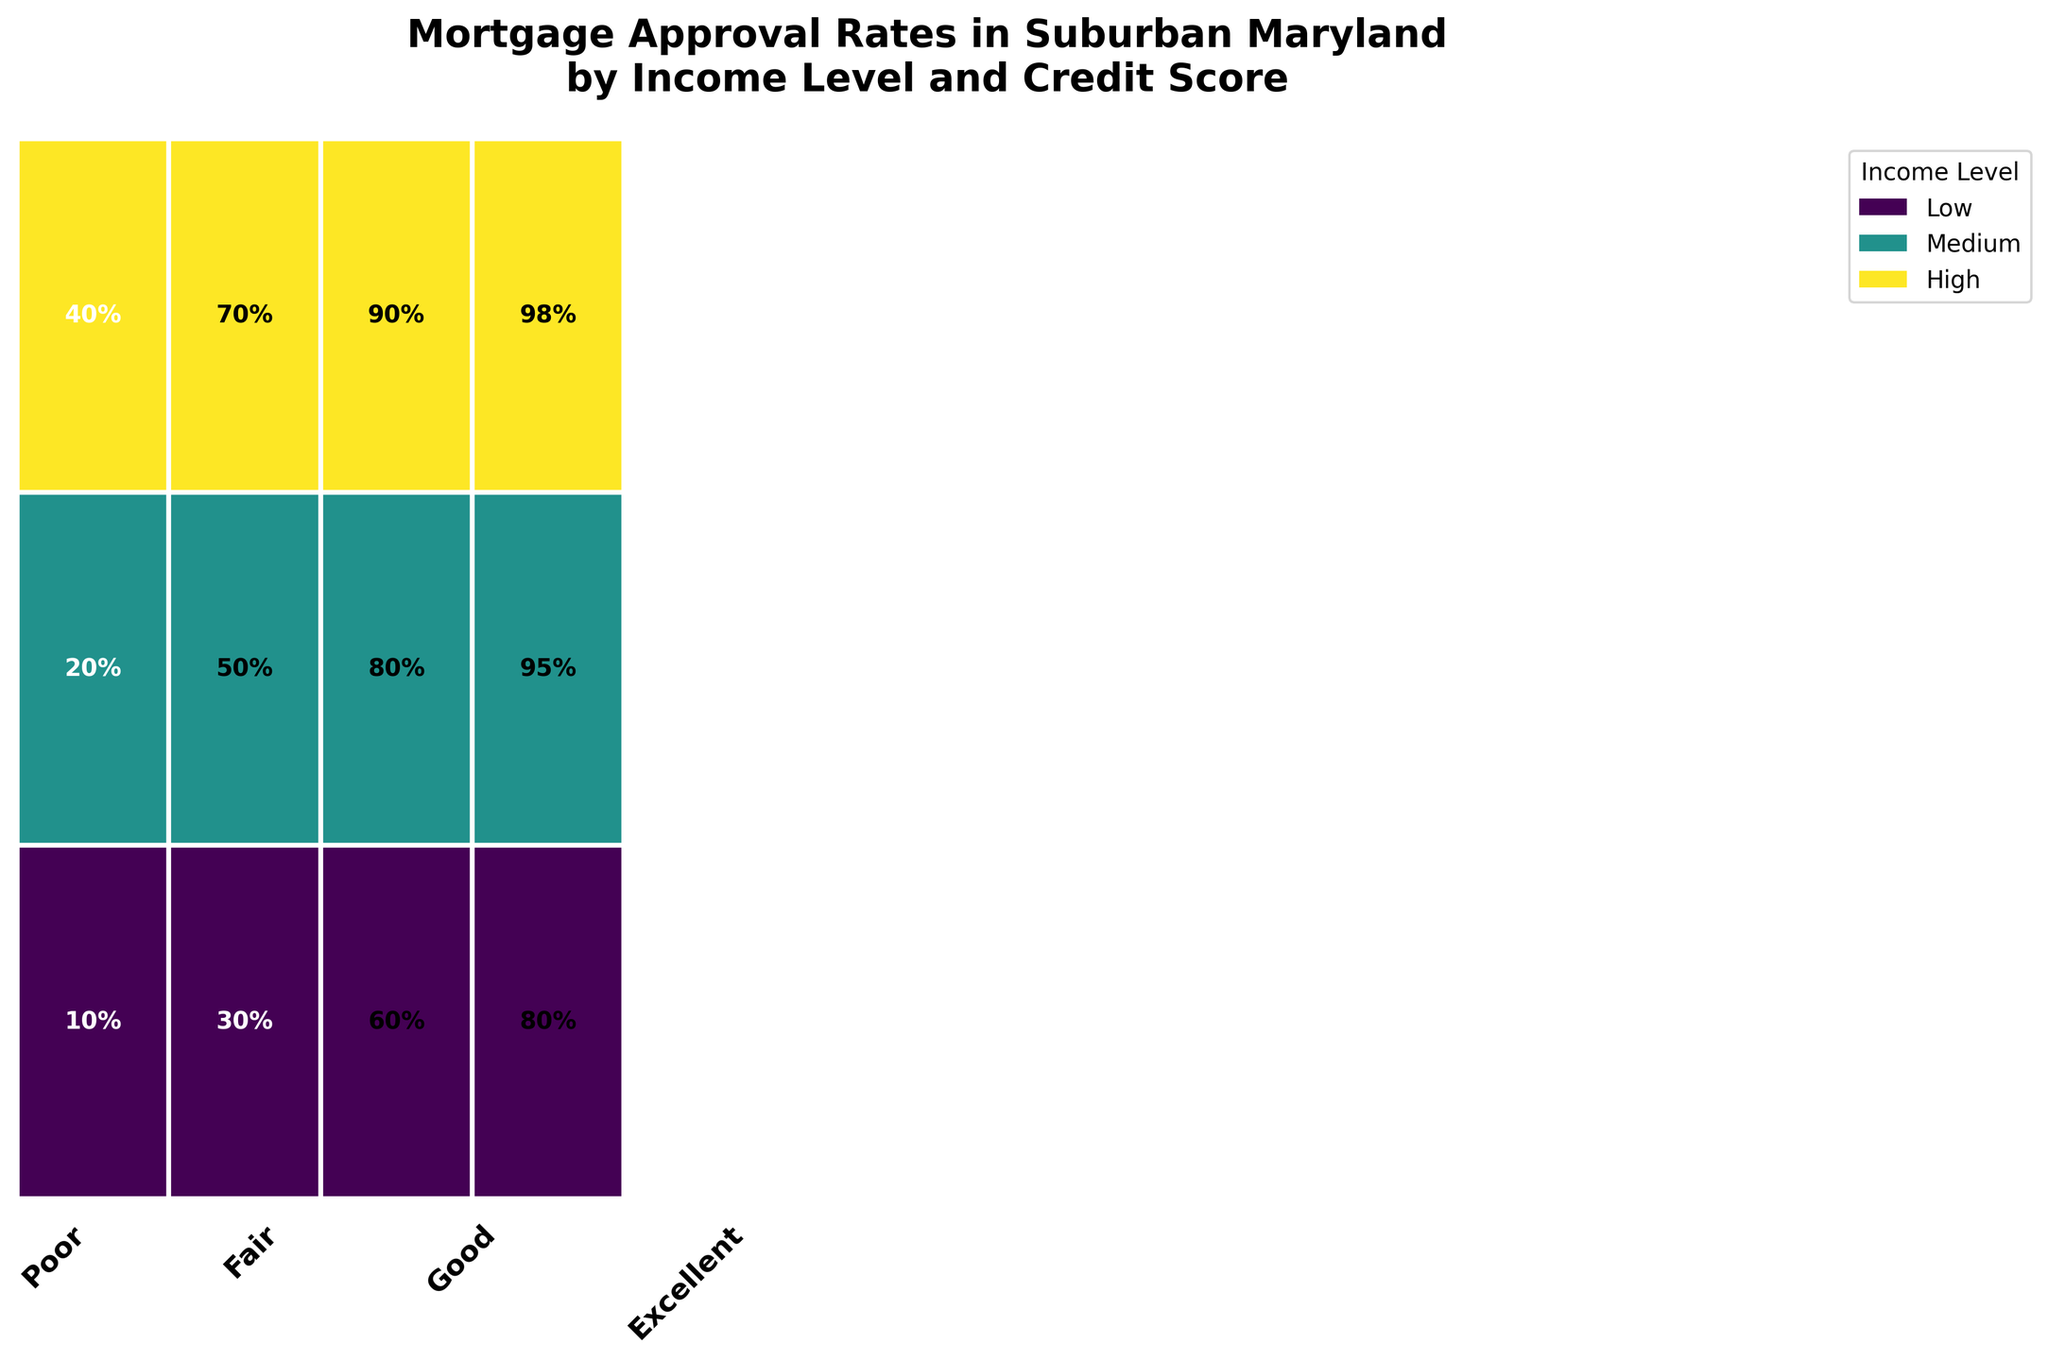What's the range of approval rates for applicants with a Low income level? Look at the rectangles corresponding to the Low income level and note the approval rates for Poor, Fair, Good, and Excellent credit scores. They range from 10% to 80%.
Answer: 10% to 80% What's the approval rate for High income level applicants with Fair credit scores? Find the rectangle for High income and Fair credit. The label in the rectangle shows the approval rate.
Answer: 70% Which credit score group has the highest mortgage approval rate for Medium income level applicants? Compare the approval rates for Poor, Fair, Good, and Excellent credit scores within the Medium income level. The highest approval rate is in the Excellent credit score group.
Answer: Excellent How does the approval rate for Medium income applicants with Excellent credit compare to that of Low income applicants with the same credit score? Find and compare the rectangles for Medium and Low income levels with Excellent credit scores. The approval rate is higher for Medium income (95%) compared to Low income (80%).
Answer: Medium income is higher What is the total number of applications for Medium income level and Poor credit score? The explanation requires summing the counts of approved and denied applications. The mosaic plot does not provide exact counts, but data indicates 20 approved and 80 denied, summing to 100.
Answer: 100 What pattern do you observe in mortgage approval rates as credit scores improve, across all income levels? The rectangles show higher approval rates as credit scores improve from Poor to Excellent, regardless of the income level.
Answer: Approval rates increase with better credit scores Which income level shows the lowest variability in approval rates across different credit scores? Evaluate the range of approval rates across Poor, Fair, Good, and Excellent credit scores for each income level. Medium income levels have the smallest range from 20% to 95%.
Answer: Medium In the High-income category, which two credit score groups have the most significant difference in approval rates? Compare the approval rates for each credit score within the High-income category. The most significant difference is between Poor (40%) and Excellent (98%).
Answer: Poor and Excellent What is the width of the rectangle for High income and Excellent credit score compared to other rectangles? This requires looking at the visual width of the rectangle for High income and Excellent credit and comparing it with others. It is one of the widest, indicating a high number of applications.
Answer: Widest Is there any income level where applicants with Poor credit scores have a higher approval rate than those with a Fair credit score? Compare approval rates for Poor and Fair credit scores across Low, Medium, and High income levels. In all cases, approval rates for Fair credit scores exceed those for Poor credit scores.
Answer: No 